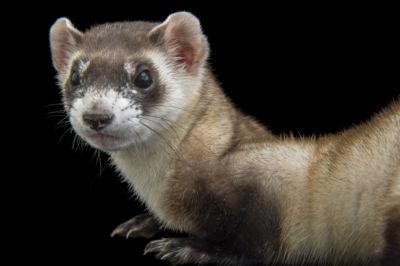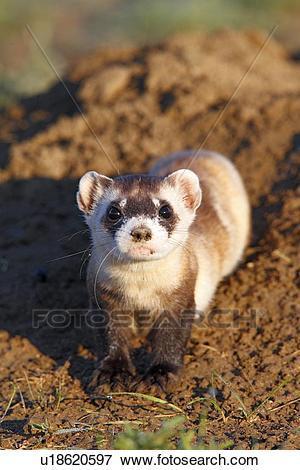The first image is the image on the left, the second image is the image on the right. Given the left and right images, does the statement "Each image contains one ferret standing on dirt ground, with at least one front and one back paw on the ground." hold true? Answer yes or no. No. The first image is the image on the left, the second image is the image on the right. Given the left and right images, does the statement "Both animals are standing on all fours on the ground." hold true? Answer yes or no. No. 